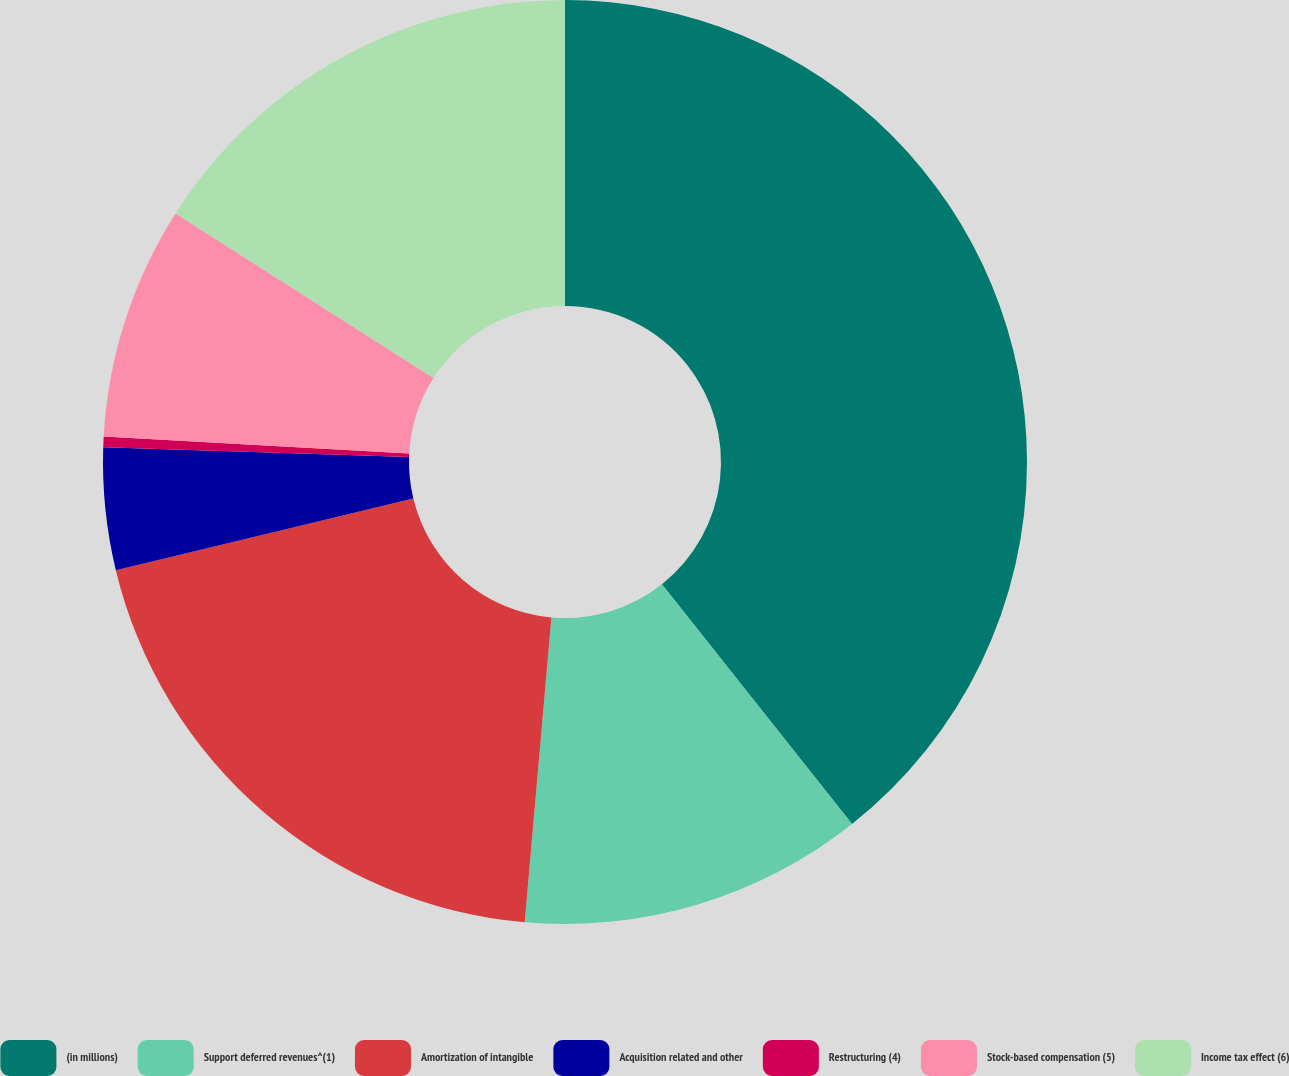<chart> <loc_0><loc_0><loc_500><loc_500><pie_chart><fcel>(in millions)<fcel>Support deferred revenues^(1)<fcel>Amortization of intangible<fcel>Acquisition related and other<fcel>Restructuring (4)<fcel>Stock-based compensation (5)<fcel>Income tax effect (6)<nl><fcel>39.33%<fcel>12.06%<fcel>19.85%<fcel>4.27%<fcel>0.37%<fcel>8.16%<fcel>15.96%<nl></chart> 